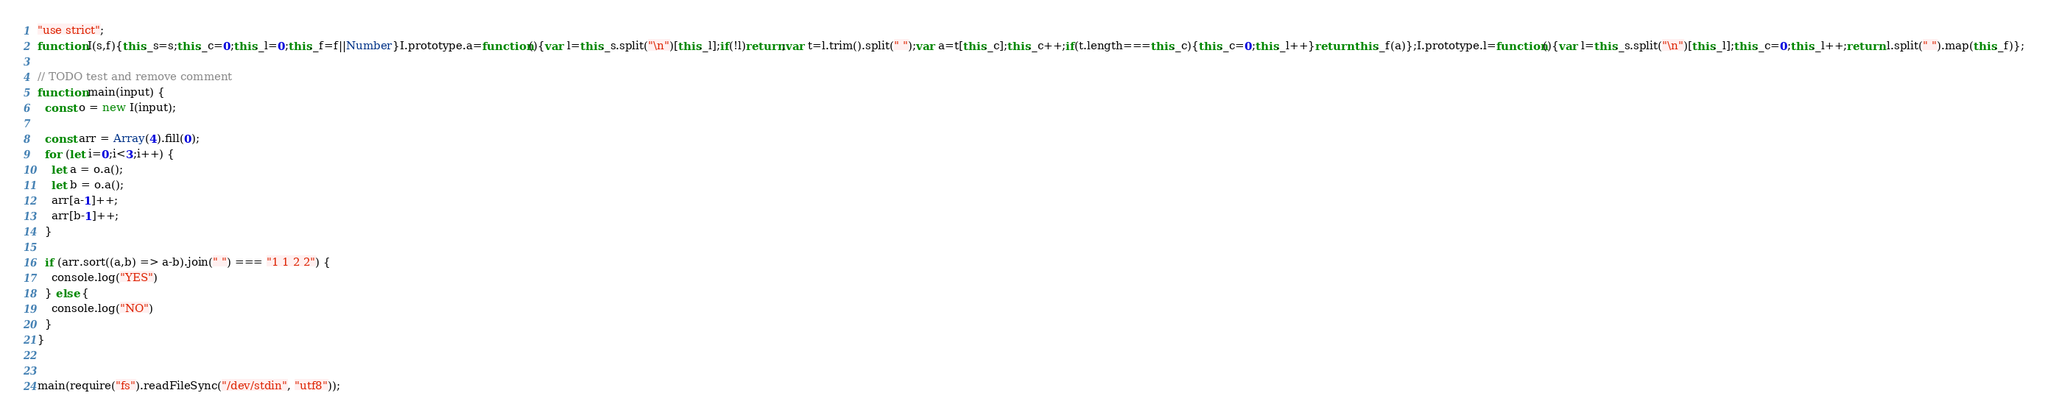Convert code to text. <code><loc_0><loc_0><loc_500><loc_500><_JavaScript_>"use strict";
function I(s,f){this._s=s;this._c=0;this._l=0;this._f=f||Number}I.prototype.a=function(){var l=this._s.split("\n")[this._l];if(!l)return;var t=l.trim().split(" ");var a=t[this._c];this._c++;if(t.length===this._c){this._c=0;this._l++}return this._f(a)};I.prototype.l=function(){var l=this._s.split("\n")[this._l];this._c=0;this._l++;return l.split(" ").map(this._f)};

// TODO test and remove comment
function main(input) {
  const o = new I(input);

  const arr = Array(4).fill(0);
  for (let i=0;i<3;i++) {
    let a = o.a();
    let b = o.a();
    arr[a-1]++;
    arr[b-1]++;
  }

  if (arr.sort((a,b) => a-b).join(" ") === "1 1 2 2") {
    console.log("YES")
  } else {
    console.log("NO")
  }
}


main(require("fs").readFileSync("/dev/stdin", "utf8"));
</code> 